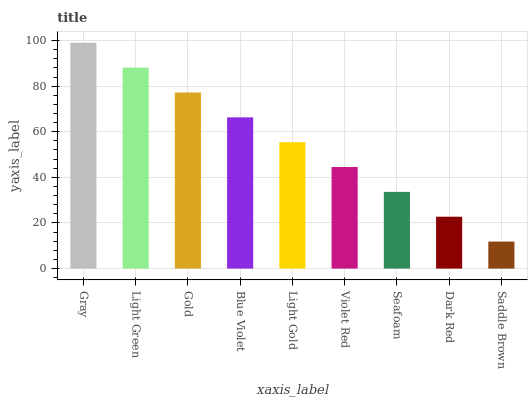Is Saddle Brown the minimum?
Answer yes or no. Yes. Is Gray the maximum?
Answer yes or no. Yes. Is Light Green the minimum?
Answer yes or no. No. Is Light Green the maximum?
Answer yes or no. No. Is Gray greater than Light Green?
Answer yes or no. Yes. Is Light Green less than Gray?
Answer yes or no. Yes. Is Light Green greater than Gray?
Answer yes or no. No. Is Gray less than Light Green?
Answer yes or no. No. Is Light Gold the high median?
Answer yes or no. Yes. Is Light Gold the low median?
Answer yes or no. Yes. Is Violet Red the high median?
Answer yes or no. No. Is Saddle Brown the low median?
Answer yes or no. No. 